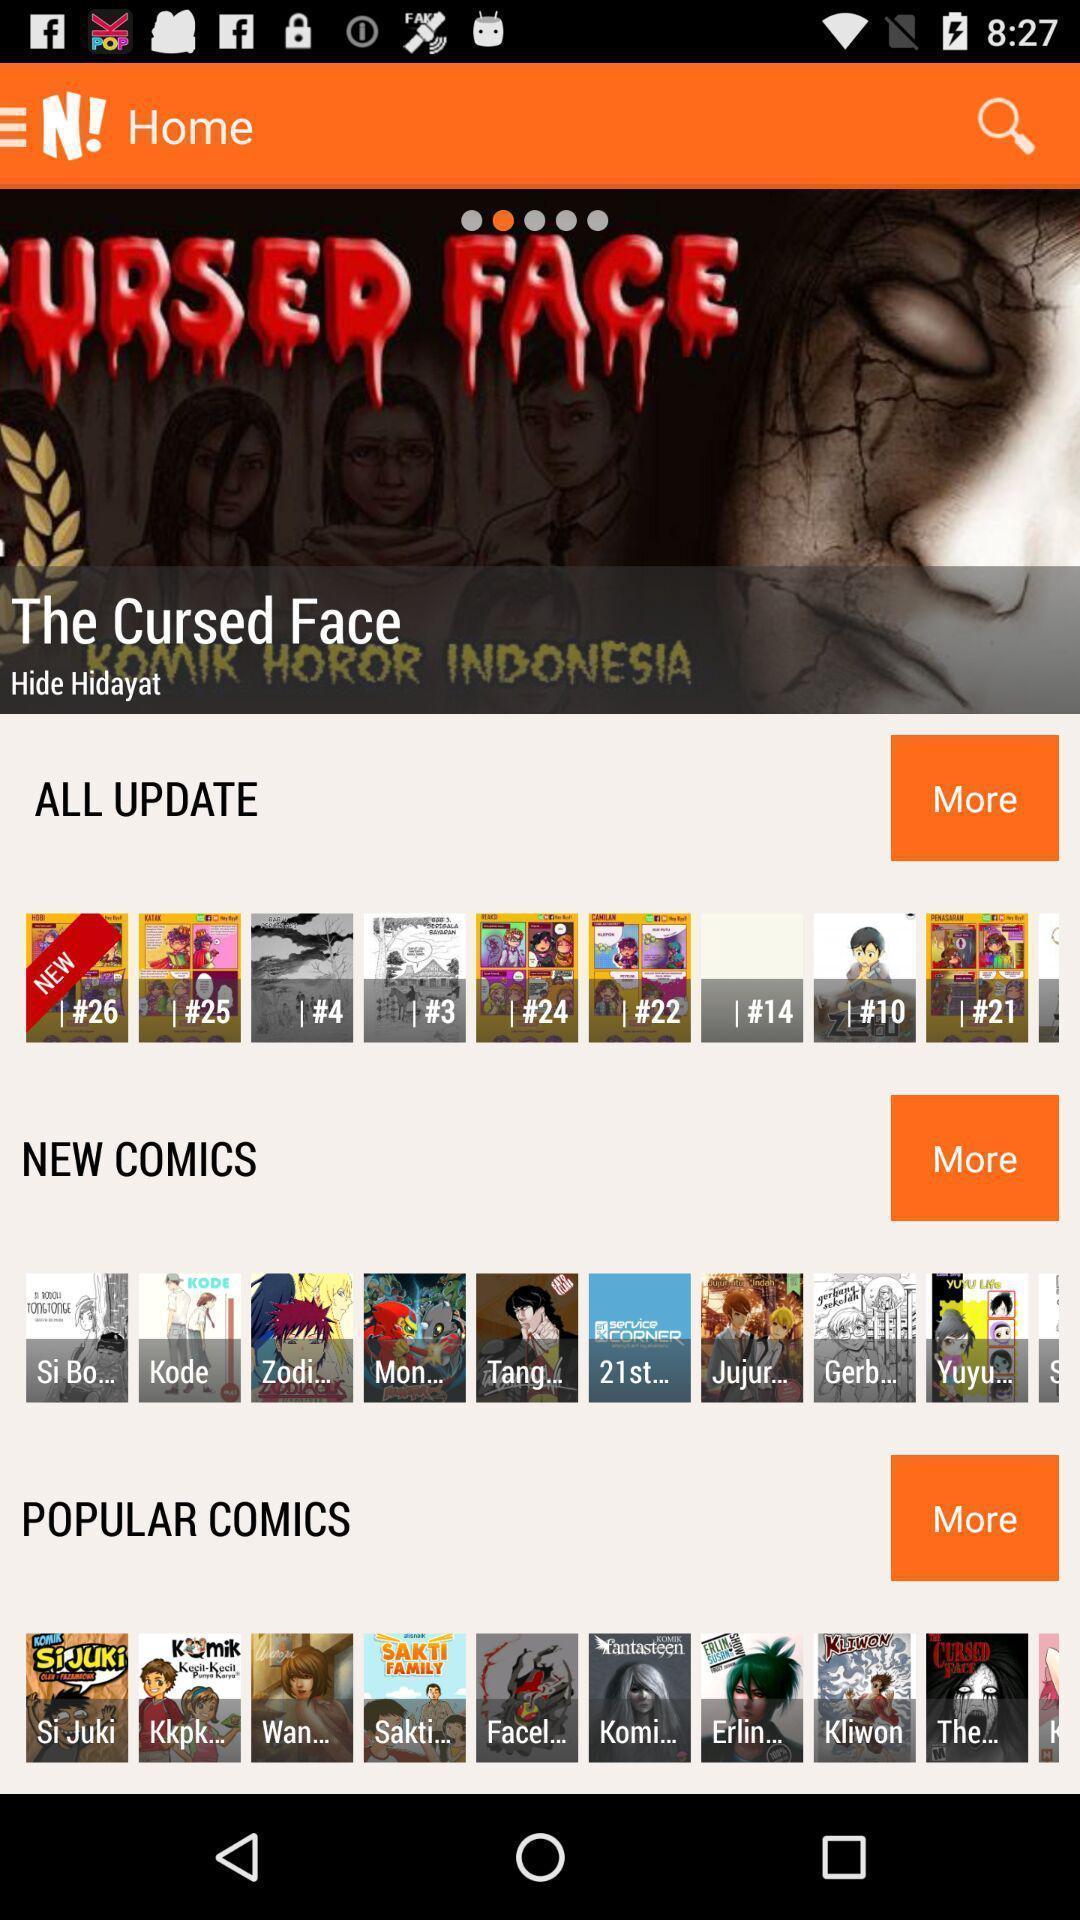Give me a narrative description of this picture. Screen page with various categories. 